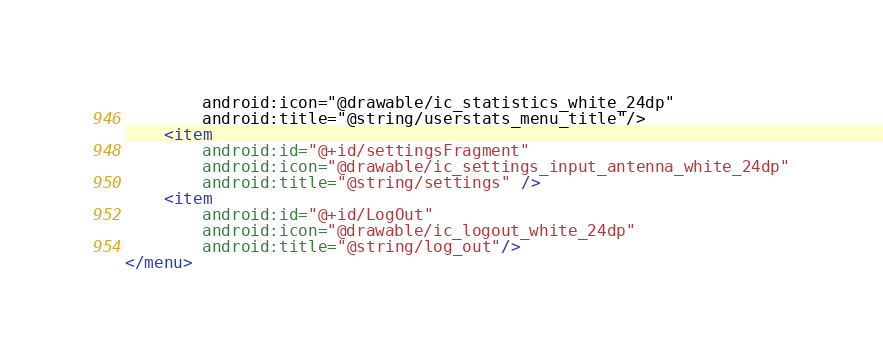Convert code to text. <code><loc_0><loc_0><loc_500><loc_500><_XML_>        android:icon="@drawable/ic_statistics_white_24dp"
        android:title="@string/userstats_menu_title"/>
    <item
        android:id="@+id/settingsFragment"
        android:icon="@drawable/ic_settings_input_antenna_white_24dp"
        android:title="@string/settings" />
    <item
        android:id="@+id/LogOut"
        android:icon="@drawable/ic_logout_white_24dp"
        android:title="@string/log_out"/>
</menu>
</code> 